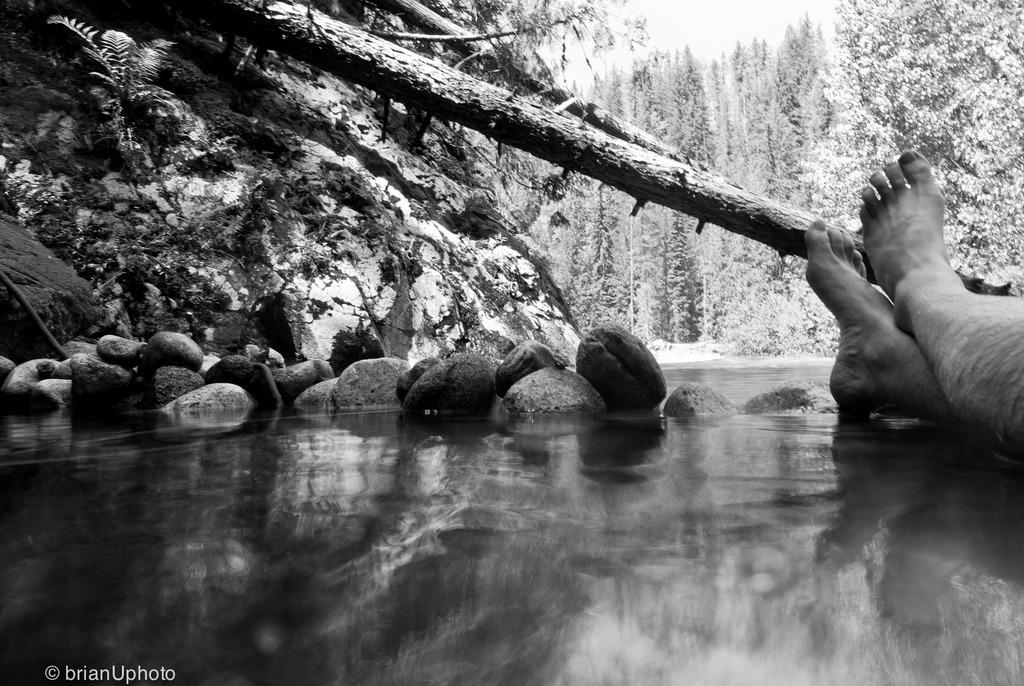What is on the surface that can be seen in the image? There are stones on the surface in the image. What part of a plant is visible in the image? A part of a tree is visible in the image. Whose legs are visible in the image? There are a person's legs in the image. What can be seen in the background of the image? Trees are present in the background of the image. How much rain is falling in the image? There is no rain visible in the image, so it is not possible to determine the amount of rain. What type of weather can be seen in the image? The image does not provide information about the weather, as it only shows stones, a part of a tree, a person's legs, and trees in the background. 